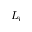<formula> <loc_0><loc_0><loc_500><loc_500>L _ { i }</formula> 